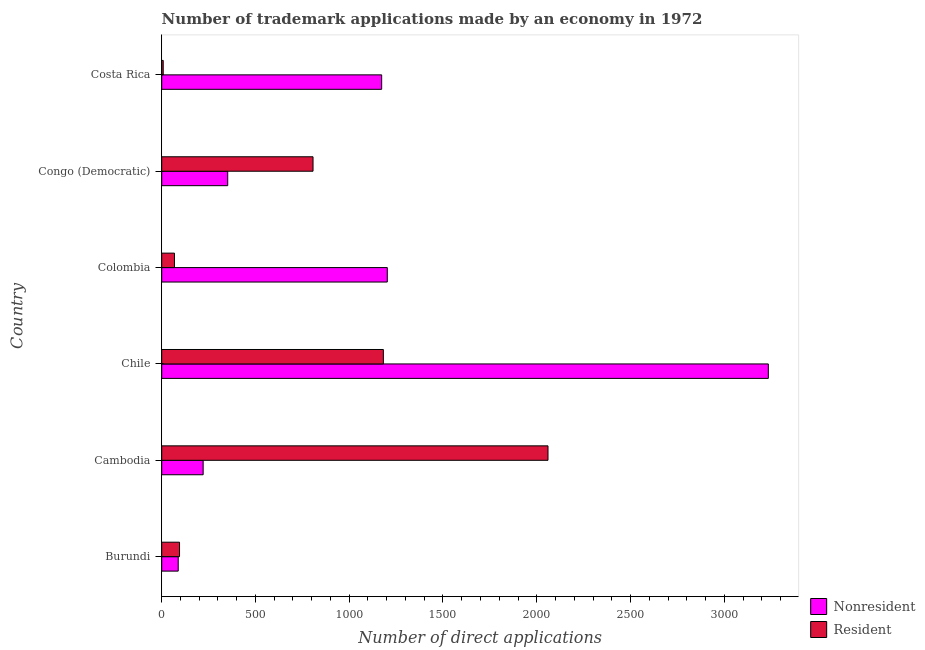Are the number of bars per tick equal to the number of legend labels?
Provide a succinct answer. Yes. How many bars are there on the 4th tick from the top?
Make the answer very short. 2. What is the label of the 2nd group of bars from the top?
Make the answer very short. Congo (Democratic). In how many cases, is the number of bars for a given country not equal to the number of legend labels?
Your answer should be compact. 0. What is the number of trademark applications made by non residents in Costa Rica?
Make the answer very short. 1173. Across all countries, what is the maximum number of trademark applications made by residents?
Ensure brevity in your answer.  2060. Across all countries, what is the minimum number of trademark applications made by residents?
Provide a succinct answer. 8. In which country was the number of trademark applications made by residents maximum?
Provide a short and direct response. Cambodia. In which country was the number of trademark applications made by residents minimum?
Ensure brevity in your answer.  Costa Rica. What is the total number of trademark applications made by residents in the graph?
Your answer should be very brief. 4220. What is the difference between the number of trademark applications made by non residents in Burundi and that in Colombia?
Keep it short and to the point. -1115. What is the difference between the number of trademark applications made by residents in Cambodia and the number of trademark applications made by non residents in Chile?
Give a very brief answer. -1175. What is the average number of trademark applications made by residents per country?
Your answer should be compact. 703.33. What is the difference between the number of trademark applications made by residents and number of trademark applications made by non residents in Cambodia?
Make the answer very short. 1839. What is the ratio of the number of trademark applications made by non residents in Colombia to that in Costa Rica?
Offer a terse response. 1.03. What is the difference between the highest and the second highest number of trademark applications made by residents?
Your response must be concise. 878. What is the difference between the highest and the lowest number of trademark applications made by residents?
Your answer should be compact. 2052. Is the sum of the number of trademark applications made by non residents in Congo (Democratic) and Costa Rica greater than the maximum number of trademark applications made by residents across all countries?
Ensure brevity in your answer.  No. What does the 1st bar from the top in Costa Rica represents?
Make the answer very short. Resident. What does the 2nd bar from the bottom in Costa Rica represents?
Keep it short and to the point. Resident. How many countries are there in the graph?
Provide a succinct answer. 6. Are the values on the major ticks of X-axis written in scientific E-notation?
Offer a terse response. No. What is the title of the graph?
Your response must be concise. Number of trademark applications made by an economy in 1972. What is the label or title of the X-axis?
Provide a succinct answer. Number of direct applications. What is the Number of direct applications of Nonresident in Cambodia?
Your answer should be very brief. 221. What is the Number of direct applications of Resident in Cambodia?
Offer a very short reply. 2060. What is the Number of direct applications in Nonresident in Chile?
Ensure brevity in your answer.  3235. What is the Number of direct applications of Resident in Chile?
Offer a terse response. 1182. What is the Number of direct applications in Nonresident in Colombia?
Offer a terse response. 1203. What is the Number of direct applications in Nonresident in Congo (Democratic)?
Offer a terse response. 352. What is the Number of direct applications of Resident in Congo (Democratic)?
Your answer should be very brief. 807. What is the Number of direct applications of Nonresident in Costa Rica?
Provide a succinct answer. 1173. Across all countries, what is the maximum Number of direct applications of Nonresident?
Ensure brevity in your answer.  3235. Across all countries, what is the maximum Number of direct applications of Resident?
Keep it short and to the point. 2060. What is the total Number of direct applications in Nonresident in the graph?
Your answer should be very brief. 6272. What is the total Number of direct applications in Resident in the graph?
Provide a succinct answer. 4220. What is the difference between the Number of direct applications of Nonresident in Burundi and that in Cambodia?
Your answer should be very brief. -133. What is the difference between the Number of direct applications in Resident in Burundi and that in Cambodia?
Keep it short and to the point. -1965. What is the difference between the Number of direct applications in Nonresident in Burundi and that in Chile?
Make the answer very short. -3147. What is the difference between the Number of direct applications in Resident in Burundi and that in Chile?
Ensure brevity in your answer.  -1087. What is the difference between the Number of direct applications in Nonresident in Burundi and that in Colombia?
Offer a very short reply. -1115. What is the difference between the Number of direct applications in Resident in Burundi and that in Colombia?
Keep it short and to the point. 27. What is the difference between the Number of direct applications of Nonresident in Burundi and that in Congo (Democratic)?
Keep it short and to the point. -264. What is the difference between the Number of direct applications in Resident in Burundi and that in Congo (Democratic)?
Your answer should be very brief. -712. What is the difference between the Number of direct applications in Nonresident in Burundi and that in Costa Rica?
Provide a succinct answer. -1085. What is the difference between the Number of direct applications in Nonresident in Cambodia and that in Chile?
Your response must be concise. -3014. What is the difference between the Number of direct applications in Resident in Cambodia and that in Chile?
Make the answer very short. 878. What is the difference between the Number of direct applications of Nonresident in Cambodia and that in Colombia?
Your response must be concise. -982. What is the difference between the Number of direct applications of Resident in Cambodia and that in Colombia?
Provide a succinct answer. 1992. What is the difference between the Number of direct applications in Nonresident in Cambodia and that in Congo (Democratic)?
Your response must be concise. -131. What is the difference between the Number of direct applications in Resident in Cambodia and that in Congo (Democratic)?
Your answer should be very brief. 1253. What is the difference between the Number of direct applications of Nonresident in Cambodia and that in Costa Rica?
Provide a succinct answer. -952. What is the difference between the Number of direct applications of Resident in Cambodia and that in Costa Rica?
Provide a succinct answer. 2052. What is the difference between the Number of direct applications in Nonresident in Chile and that in Colombia?
Keep it short and to the point. 2032. What is the difference between the Number of direct applications in Resident in Chile and that in Colombia?
Offer a very short reply. 1114. What is the difference between the Number of direct applications in Nonresident in Chile and that in Congo (Democratic)?
Your answer should be very brief. 2883. What is the difference between the Number of direct applications of Resident in Chile and that in Congo (Democratic)?
Provide a short and direct response. 375. What is the difference between the Number of direct applications in Nonresident in Chile and that in Costa Rica?
Your answer should be compact. 2062. What is the difference between the Number of direct applications of Resident in Chile and that in Costa Rica?
Your response must be concise. 1174. What is the difference between the Number of direct applications of Nonresident in Colombia and that in Congo (Democratic)?
Offer a terse response. 851. What is the difference between the Number of direct applications of Resident in Colombia and that in Congo (Democratic)?
Your answer should be very brief. -739. What is the difference between the Number of direct applications of Nonresident in Colombia and that in Costa Rica?
Your response must be concise. 30. What is the difference between the Number of direct applications of Nonresident in Congo (Democratic) and that in Costa Rica?
Offer a very short reply. -821. What is the difference between the Number of direct applications in Resident in Congo (Democratic) and that in Costa Rica?
Ensure brevity in your answer.  799. What is the difference between the Number of direct applications of Nonresident in Burundi and the Number of direct applications of Resident in Cambodia?
Your answer should be compact. -1972. What is the difference between the Number of direct applications in Nonresident in Burundi and the Number of direct applications in Resident in Chile?
Give a very brief answer. -1094. What is the difference between the Number of direct applications of Nonresident in Burundi and the Number of direct applications of Resident in Colombia?
Offer a terse response. 20. What is the difference between the Number of direct applications of Nonresident in Burundi and the Number of direct applications of Resident in Congo (Democratic)?
Provide a short and direct response. -719. What is the difference between the Number of direct applications in Nonresident in Burundi and the Number of direct applications in Resident in Costa Rica?
Make the answer very short. 80. What is the difference between the Number of direct applications of Nonresident in Cambodia and the Number of direct applications of Resident in Chile?
Offer a very short reply. -961. What is the difference between the Number of direct applications in Nonresident in Cambodia and the Number of direct applications in Resident in Colombia?
Provide a short and direct response. 153. What is the difference between the Number of direct applications of Nonresident in Cambodia and the Number of direct applications of Resident in Congo (Democratic)?
Your response must be concise. -586. What is the difference between the Number of direct applications in Nonresident in Cambodia and the Number of direct applications in Resident in Costa Rica?
Make the answer very short. 213. What is the difference between the Number of direct applications of Nonresident in Chile and the Number of direct applications of Resident in Colombia?
Your answer should be very brief. 3167. What is the difference between the Number of direct applications of Nonresident in Chile and the Number of direct applications of Resident in Congo (Democratic)?
Provide a succinct answer. 2428. What is the difference between the Number of direct applications in Nonresident in Chile and the Number of direct applications in Resident in Costa Rica?
Your response must be concise. 3227. What is the difference between the Number of direct applications of Nonresident in Colombia and the Number of direct applications of Resident in Congo (Democratic)?
Provide a short and direct response. 396. What is the difference between the Number of direct applications in Nonresident in Colombia and the Number of direct applications in Resident in Costa Rica?
Your response must be concise. 1195. What is the difference between the Number of direct applications in Nonresident in Congo (Democratic) and the Number of direct applications in Resident in Costa Rica?
Your response must be concise. 344. What is the average Number of direct applications in Nonresident per country?
Give a very brief answer. 1045.33. What is the average Number of direct applications in Resident per country?
Offer a terse response. 703.33. What is the difference between the Number of direct applications in Nonresident and Number of direct applications in Resident in Burundi?
Make the answer very short. -7. What is the difference between the Number of direct applications in Nonresident and Number of direct applications in Resident in Cambodia?
Give a very brief answer. -1839. What is the difference between the Number of direct applications in Nonresident and Number of direct applications in Resident in Chile?
Keep it short and to the point. 2053. What is the difference between the Number of direct applications in Nonresident and Number of direct applications in Resident in Colombia?
Offer a terse response. 1135. What is the difference between the Number of direct applications of Nonresident and Number of direct applications of Resident in Congo (Democratic)?
Provide a succinct answer. -455. What is the difference between the Number of direct applications of Nonresident and Number of direct applications of Resident in Costa Rica?
Offer a very short reply. 1165. What is the ratio of the Number of direct applications in Nonresident in Burundi to that in Cambodia?
Give a very brief answer. 0.4. What is the ratio of the Number of direct applications in Resident in Burundi to that in Cambodia?
Give a very brief answer. 0.05. What is the ratio of the Number of direct applications of Nonresident in Burundi to that in Chile?
Ensure brevity in your answer.  0.03. What is the ratio of the Number of direct applications of Resident in Burundi to that in Chile?
Your response must be concise. 0.08. What is the ratio of the Number of direct applications in Nonresident in Burundi to that in Colombia?
Provide a short and direct response. 0.07. What is the ratio of the Number of direct applications of Resident in Burundi to that in Colombia?
Provide a short and direct response. 1.4. What is the ratio of the Number of direct applications in Nonresident in Burundi to that in Congo (Democratic)?
Provide a succinct answer. 0.25. What is the ratio of the Number of direct applications of Resident in Burundi to that in Congo (Democratic)?
Ensure brevity in your answer.  0.12. What is the ratio of the Number of direct applications in Nonresident in Burundi to that in Costa Rica?
Ensure brevity in your answer.  0.07. What is the ratio of the Number of direct applications in Resident in Burundi to that in Costa Rica?
Offer a very short reply. 11.88. What is the ratio of the Number of direct applications in Nonresident in Cambodia to that in Chile?
Provide a succinct answer. 0.07. What is the ratio of the Number of direct applications in Resident in Cambodia to that in Chile?
Offer a very short reply. 1.74. What is the ratio of the Number of direct applications of Nonresident in Cambodia to that in Colombia?
Make the answer very short. 0.18. What is the ratio of the Number of direct applications of Resident in Cambodia to that in Colombia?
Provide a short and direct response. 30.29. What is the ratio of the Number of direct applications in Nonresident in Cambodia to that in Congo (Democratic)?
Offer a very short reply. 0.63. What is the ratio of the Number of direct applications of Resident in Cambodia to that in Congo (Democratic)?
Offer a terse response. 2.55. What is the ratio of the Number of direct applications in Nonresident in Cambodia to that in Costa Rica?
Your response must be concise. 0.19. What is the ratio of the Number of direct applications of Resident in Cambodia to that in Costa Rica?
Offer a terse response. 257.5. What is the ratio of the Number of direct applications in Nonresident in Chile to that in Colombia?
Your answer should be compact. 2.69. What is the ratio of the Number of direct applications of Resident in Chile to that in Colombia?
Give a very brief answer. 17.38. What is the ratio of the Number of direct applications in Nonresident in Chile to that in Congo (Democratic)?
Keep it short and to the point. 9.19. What is the ratio of the Number of direct applications of Resident in Chile to that in Congo (Democratic)?
Your answer should be compact. 1.46. What is the ratio of the Number of direct applications in Nonresident in Chile to that in Costa Rica?
Provide a short and direct response. 2.76. What is the ratio of the Number of direct applications of Resident in Chile to that in Costa Rica?
Provide a succinct answer. 147.75. What is the ratio of the Number of direct applications in Nonresident in Colombia to that in Congo (Democratic)?
Your response must be concise. 3.42. What is the ratio of the Number of direct applications in Resident in Colombia to that in Congo (Democratic)?
Your answer should be very brief. 0.08. What is the ratio of the Number of direct applications in Nonresident in Colombia to that in Costa Rica?
Your answer should be compact. 1.03. What is the ratio of the Number of direct applications in Nonresident in Congo (Democratic) to that in Costa Rica?
Your answer should be very brief. 0.3. What is the ratio of the Number of direct applications in Resident in Congo (Democratic) to that in Costa Rica?
Provide a short and direct response. 100.88. What is the difference between the highest and the second highest Number of direct applications of Nonresident?
Your answer should be compact. 2032. What is the difference between the highest and the second highest Number of direct applications of Resident?
Your answer should be compact. 878. What is the difference between the highest and the lowest Number of direct applications of Nonresident?
Give a very brief answer. 3147. What is the difference between the highest and the lowest Number of direct applications of Resident?
Give a very brief answer. 2052. 